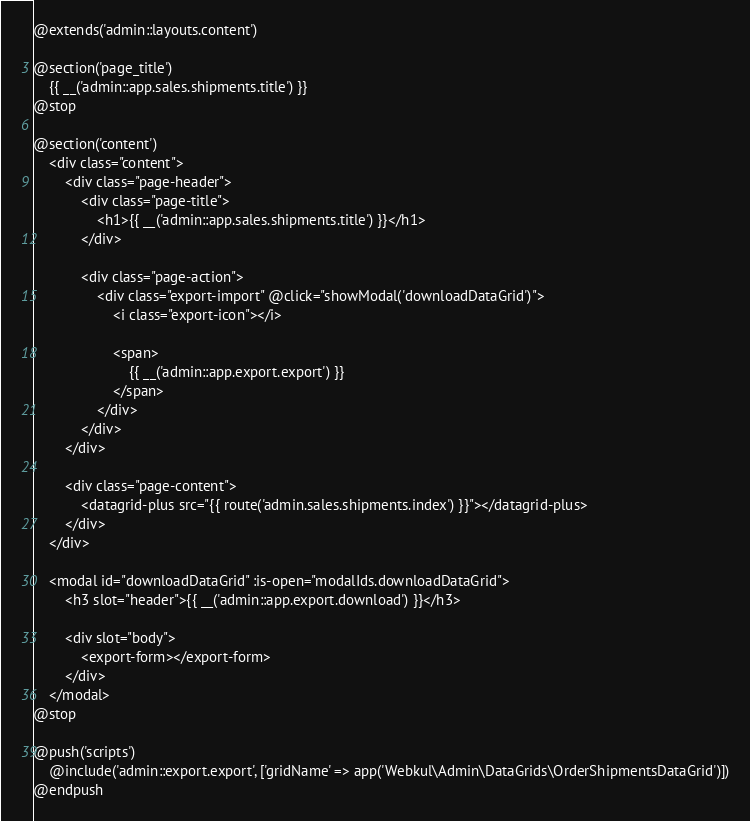<code> <loc_0><loc_0><loc_500><loc_500><_PHP_>@extends('admin::layouts.content')

@section('page_title')
    {{ __('admin::app.sales.shipments.title') }}
@stop

@section('content')
    <div class="content">
        <div class="page-header">
            <div class="page-title">
                <h1>{{ __('admin::app.sales.shipments.title') }}</h1>
            </div>

            <div class="page-action">
                <div class="export-import" @click="showModal('downloadDataGrid')">
                    <i class="export-icon"></i>

                    <span>
                        {{ __('admin::app.export.export') }}
                    </span>
                </div>
            </div>
        </div>

        <div class="page-content">
            <datagrid-plus src="{{ route('admin.sales.shipments.index') }}"></datagrid-plus>
        </div>
    </div>

    <modal id="downloadDataGrid" :is-open="modalIds.downloadDataGrid">
        <h3 slot="header">{{ __('admin::app.export.download') }}</h3>

        <div slot="body">
            <export-form></export-form>
        </div>
    </modal>
@stop

@push('scripts')
    @include('admin::export.export', ['gridName' => app('Webkul\Admin\DataGrids\OrderShipmentsDataGrid')])
@endpush
</code> 